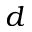<formula> <loc_0><loc_0><loc_500><loc_500>d</formula> 